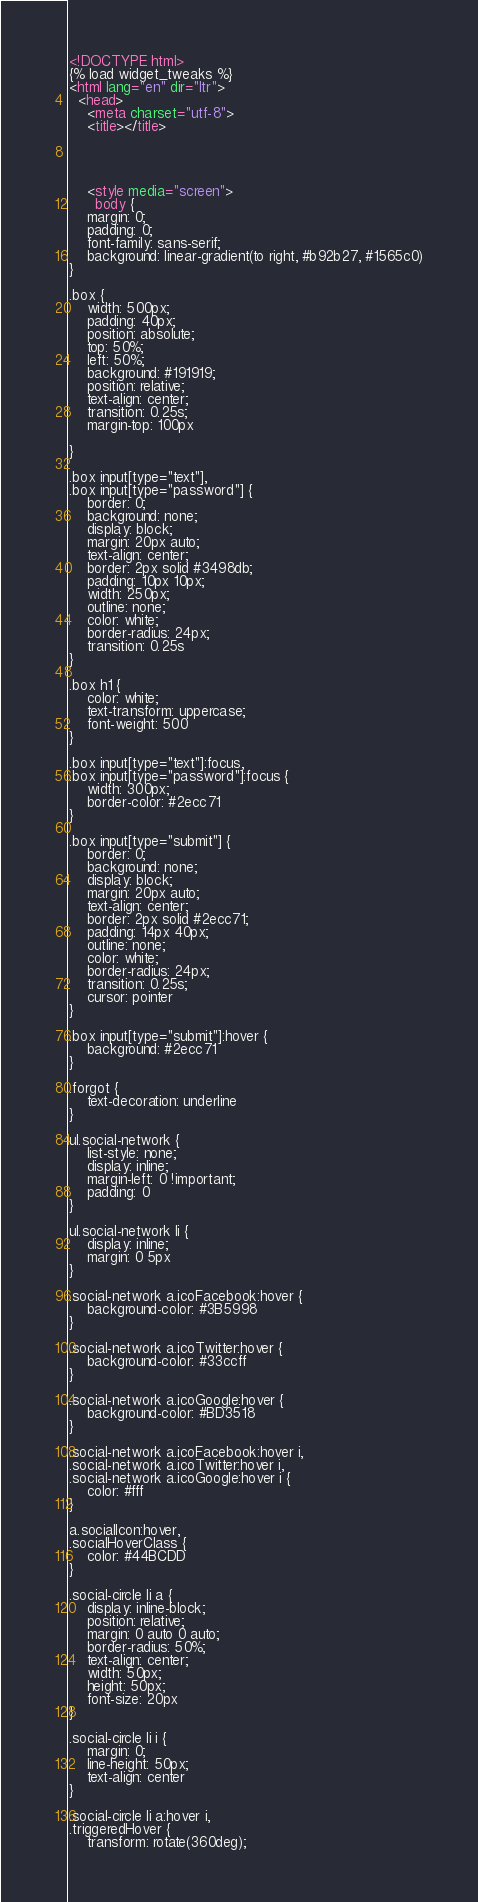<code> <loc_0><loc_0><loc_500><loc_500><_HTML_><!DOCTYPE html>
{% load widget_tweaks %}
<html lang="en" dir="ltr">
  <head>
    <meta charset="utf-8">
    <title></title>




    <style media="screen">
      body {
    margin: 0;
    padding: 0;
    font-family: sans-serif;
    background: linear-gradient(to right, #b92b27, #1565c0)
}

.box {
    width: 500px;
    padding: 40px;
    position: absolute;
    top: 50%;
    left: 50%;
    background: #191919;
    position: relative;
    text-align: center;
    transition: 0.25s;
    margin-top: 100px
    
}

.box input[type="text"],
.box input[type="password"] {
    border: 0;
    background: none;
    display: block;
    margin: 20px auto;
    text-align: center;
    border: 2px solid #3498db;
    padding: 10px 10px;
    width: 250px;
    outline: none;
    color: white;
    border-radius: 24px;
    transition: 0.25s
}

.box h1 {
    color: white;
    text-transform: uppercase;
    font-weight: 500
}

.box input[type="text"]:focus,
.box input[type="password"]:focus {
    width: 300px;
    border-color: #2ecc71
}

.box input[type="submit"] {
    border: 0;
    background: none;
    display: block;
    margin: 20px auto;
    text-align: center;
    border: 2px solid #2ecc71;
    padding: 14px 40px;
    outline: none;
    color: white;
    border-radius: 24px;
    transition: 0.25s;
    cursor: pointer
}

.box input[type="submit"]:hover {
    background: #2ecc71
}

.forgot {
    text-decoration: underline
}

ul.social-network {
    list-style: none;
    display: inline;
    margin-left: 0 !important;
    padding: 0
}

ul.social-network li {
    display: inline;
    margin: 0 5px
}

.social-network a.icoFacebook:hover {
    background-color: #3B5998
}

.social-network a.icoTwitter:hover {
    background-color: #33ccff
}

.social-network a.icoGoogle:hover {
    background-color: #BD3518
}

.social-network a.icoFacebook:hover i,
.social-network a.icoTwitter:hover i,
.social-network a.icoGoogle:hover i {
    color: #fff
}

a.socialIcon:hover,
.socialHoverClass {
    color: #44BCDD
}

.social-circle li a {
    display: inline-block;
    position: relative;
    margin: 0 auto 0 auto;
    border-radius: 50%;
    text-align: center;
    width: 50px;
    height: 50px;
    font-size: 20px
}

.social-circle li i {
    margin: 0;
    line-height: 50px;
    text-align: center
}

.social-circle li a:hover i,
.triggeredHover {
    transform: rotate(360deg);</code> 